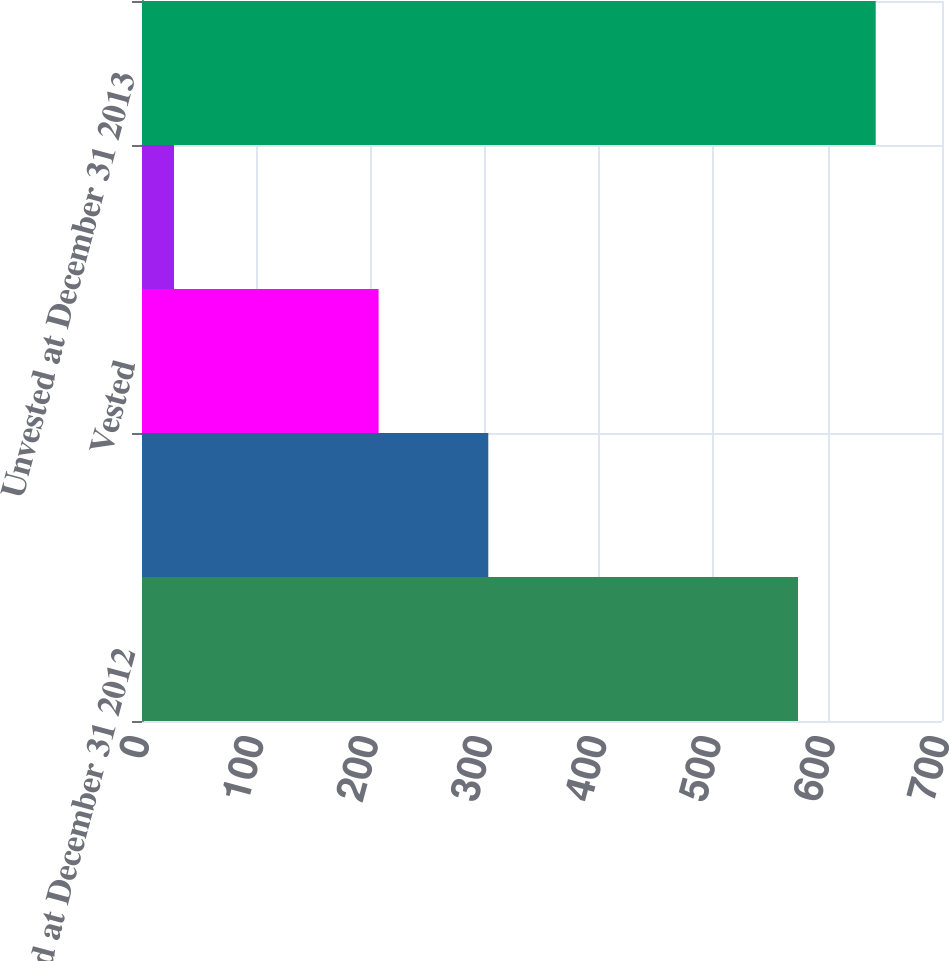Convert chart to OTSL. <chart><loc_0><loc_0><loc_500><loc_500><bar_chart><fcel>Unvested at December 31 2012<fcel>Granted<fcel>Vested<fcel>Forfeited<fcel>Unvested at December 31 2013<nl><fcel>574<fcel>303<fcel>207<fcel>28<fcel>642<nl></chart> 